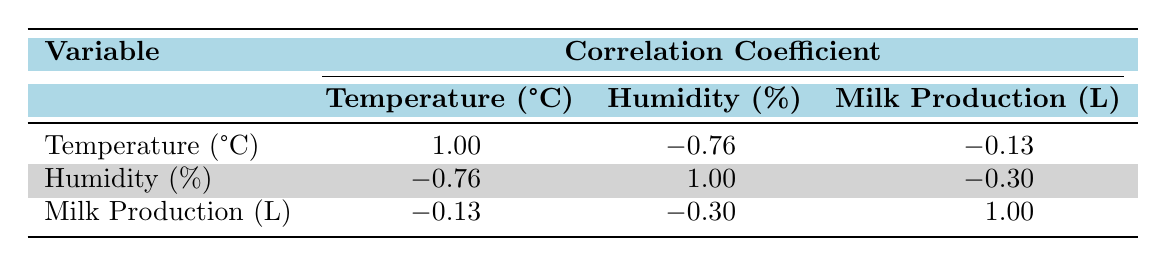What is the correlation coefficient between temperature and humidity? From the table, the correlation coefficient between temperature and humidity is -0.76, indicating a strong negative relationship. This means that as temperature increases, humidity tends to decrease.
Answer: -0.76 What is the correlation coefficient between humidity and milk production? According to the table, the correlation coefficient between humidity and milk production is -0.30, showing a moderate negative relationship. This suggests that higher humidity is somewhat associated with lower milk production.
Answer: -0.30 Is milk production positively correlated with temperature? The correlation coefficient between milk production and temperature is -0.13, which indicates a very weak negative relationship. Therefore, there is no positive correlation between milk production and temperature.
Answer: No What is the correlation coefficient between temperature and milk production? The table shows that the correlation coefficient is -0.13, which reflects a very weak negative correlation, suggesting little to no relationship between these two variables.
Answer: -0.13 What can be inferred about the relationship between temperature and milk production levels as temperature increases? Given the correlation coefficient of -0.13, we can infer that increasing temperatures do not significantly impact milk production levels, as the correlation is very weak.
Answer: Weak relationship What is the average correlation coefficient for the three pairs of variables listed? To find the average, we sum the three correlation coefficients (1.00, -0.76, -0.13), which equals 0.11. The average is then 0.11 divided by 3, giving approximately 0.037.
Answer: 0.037 How does an increase in humidity affect milk production based on the correlation coefficient? The correlation coefficient between humidity and milk production is -0.30, which suggests that an increase in humidity tends to be associated with a decrease in milk production levels. Therefore, higher humidity could negatively impact production.
Answer: Negative impact What is the highest correlation coefficient found in the table? The highest correlation coefficient in the table is 1.00, which pertains to the relationship of temperature with itself, as this is a perfect positive correlation indicating complete association.
Answer: 1.00 If the temperature increases significantly, what would you expect to happen to humidity levels based on the correlation coefficient? The correlation coefficient between temperature and humidity is -0.76. Based on this strong negative correlation, if the temperature increases significantly, we would expect humidity levels to decrease.
Answer: Decrease 